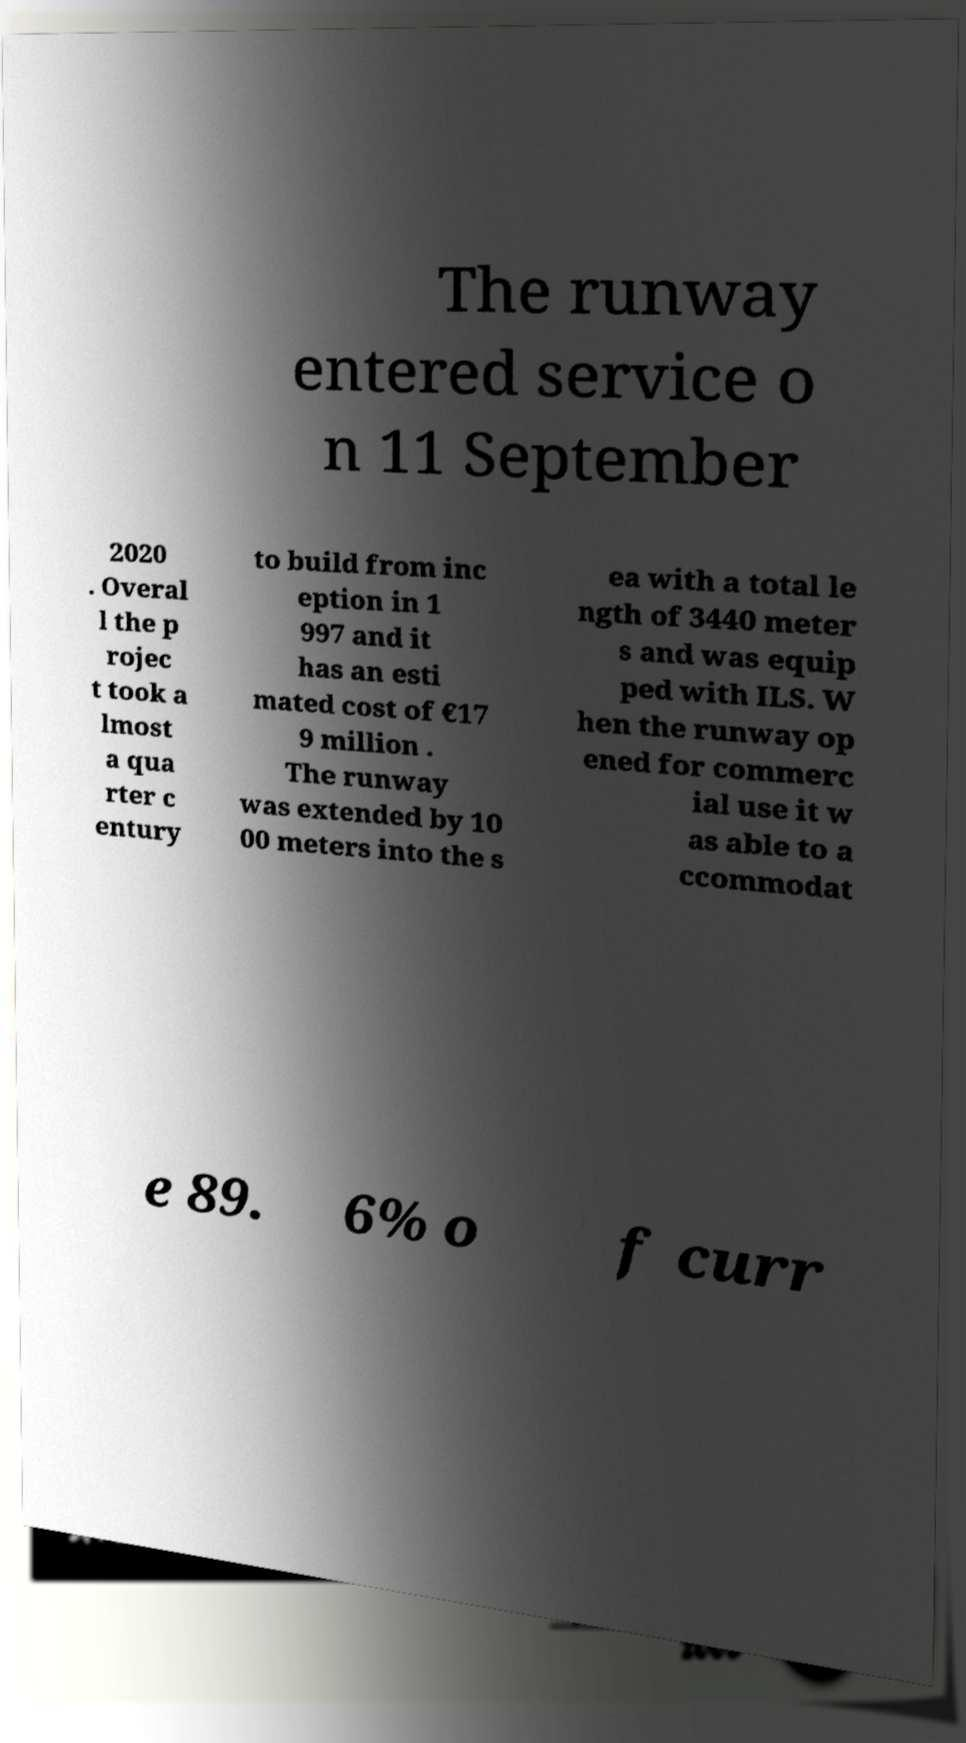Can you accurately transcribe the text from the provided image for me? The runway entered service o n 11 September 2020 . Overal l the p rojec t took a lmost a qua rter c entury to build from inc eption in 1 997 and it has an esti mated cost of €17 9 million . The runway was extended by 10 00 meters into the s ea with a total le ngth of 3440 meter s and was equip ped with ILS. W hen the runway op ened for commerc ial use it w as able to a ccommodat e 89. 6% o f curr 